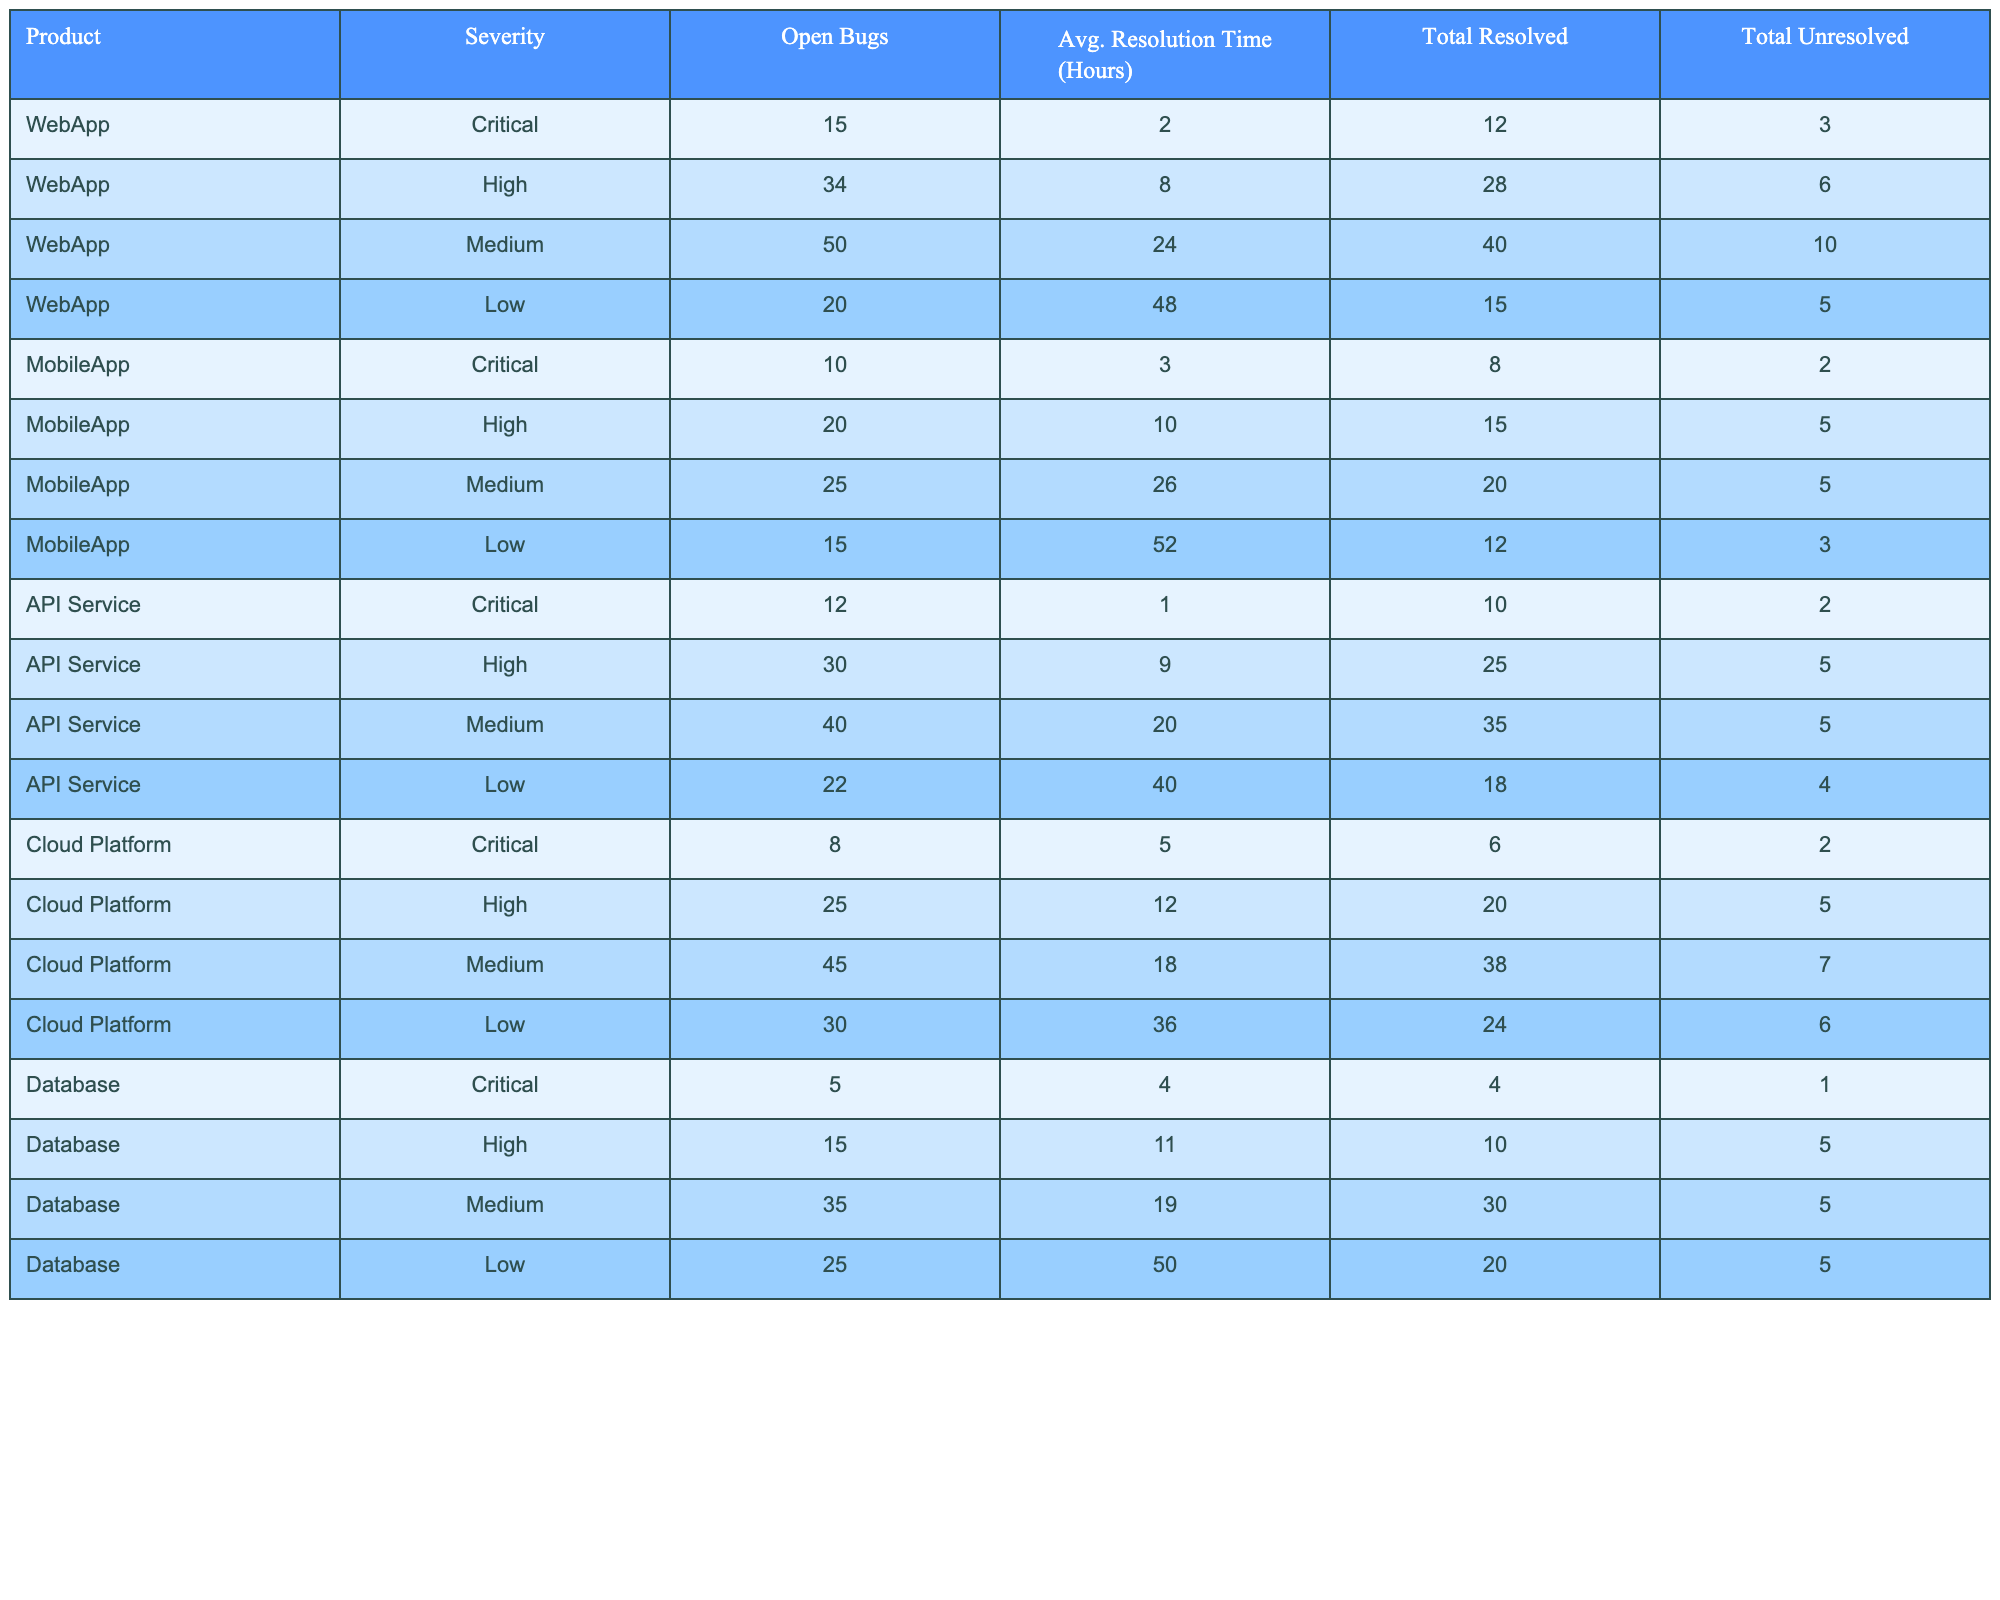What is the average resolution time for Critical severity bugs across all products? From the table, the average resolution times for Critical severity bugs by product are: WebApp (2 hours), MobileApp (3 hours), API Service (1 hour), Cloud Platform (5 hours), and Database (4 hours). To find the average, we add these values: 2 + 3 + 1 + 5 + 4 = 15. Then, divide by the number of products (5): 15/5 = 3.
Answer: 3 hours Which product has the highest number of unresolved Medium severity bugs? Looking at the table, the unresolved Medium severity bugs by product are: WebApp (10), MobileApp (5), API Service (5), Cloud Platform (7), and Database (5). The highest value among these is WebApp with 10 unresolved Medium severity bugs.
Answer: WebApp How many total bugs were resolved for the Database product? The table shows that the Database product has a Total Resolved count of 30 for Medium severity, 10 for High severity, 4 for Critical severity, and 20 for Low severity. To find the total, we add these: 30 + 10 + 4 + 20 = 64.
Answer: 64 Is the average resolution time for High severity bugs higher than for Low severity bugs in the WebApp product? The average resolution time for High severity bugs in WebApp is 8 hours, while for Low severity it is 48 hours. Comparing these values, 48 hours is higher than 8 hours. Therefore, it is true that the average resolution time for Low severity bugs is higher.
Answer: Yes Which product has the lowest average resolution time for Critical severity bugs? The average resolution times for Critical severity bugs are: WebApp (2 hours), MobileApp (3 hours), API Service (1 hour), Cloud Platform (5 hours), and Database (4 hours). The lowest average here is 1 hour from API Service.
Answer: API Service How many total unresolved bugs are present across all products? By summing the Total Unresolved bugs from each product: WebApp (3) + MobileApp (3) + API Service (5) + Cloud Platform (6) + Database (5) equals 3 + 3 + 5 + 6 + 5 = 22.
Answer: 22 What percentage of the total bugs for the MobileApp product are Critical severity? The Open Bugs for MobileApp are 20 (Critical) + 15 (High) + 25 (Medium) + 15 (Low) = 75. The Critical bugs account for 10 of those. To find the percentage, (10/75) * 100 = 13.33%.
Answer: 13.33% Which severity category has the highest number of total unresolved bugs across all products? By aggregating the Total Unresolved by severity across products, we find: Critical (14), High (26), Medium (32), and Low (28). Among these, Medium severity bugs have the highest unresolved count at 32.
Answer: Medium What is the total average resolution time for all unresolved bugs categorized as Low severity? The average resolution time for Low severity bugs are: WebApp (48 hours), MobileApp (52 hours), API Service (40 hours), Cloud Platform (36 hours), and Database (50 hours). We first add these: 48 + 52 + 40 + 36 + 50 = 226. Then, divide by the number of products (5) for an average: 226/5 = 45.2 hours.
Answer: 45.2 hours Is the resolution time for Medium severity bugs in the API Service product higher than that in the Cloud Platform product? The average resolution time for Medium severity bugs in API Service is 20 hours, while in Cloud Platform it is 18 hours. Therefore, 20 hours is greater than 18 hours, making it true that the resolution time for API Service is higher.
Answer: Yes 